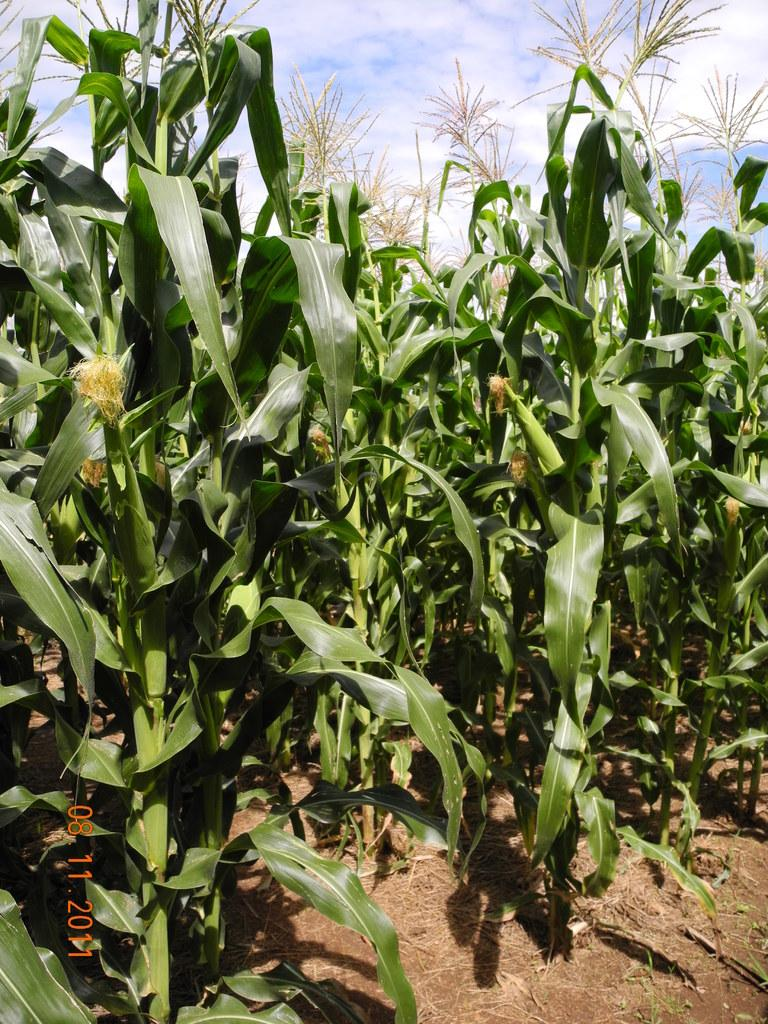What type of living organisms can be seen in the image? Plants can be seen in the image. Where is the date mentioned in the image? The date is mentioned at the left bottom of the image. What part of the natural environment is visible in the image? The sky is visible in the image. What body part is responsible for the sneeze in the image? There is no sneeze present in the image, so it is not possible to determine which body part might be responsible. 